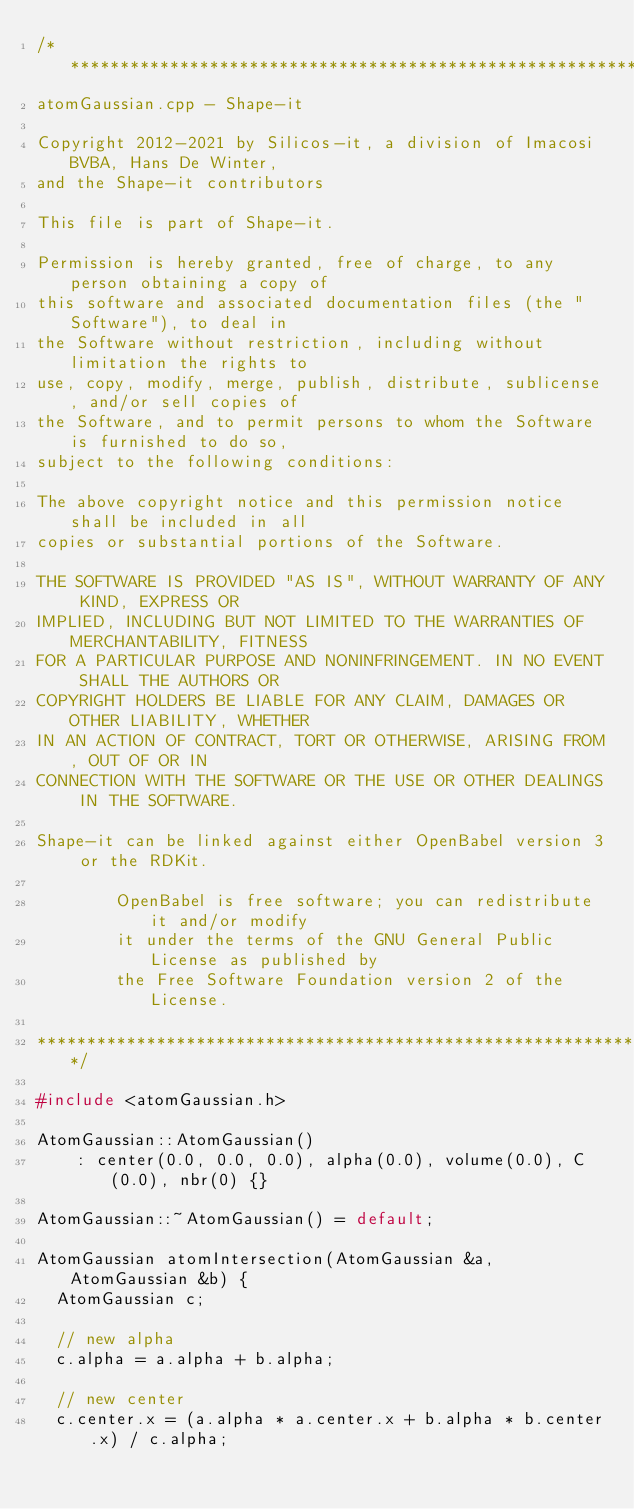<code> <loc_0><loc_0><loc_500><loc_500><_C++_>/*******************************************************************************
atomGaussian.cpp - Shape-it

Copyright 2012-2021 by Silicos-it, a division of Imacosi BVBA, Hans De Winter,
and the Shape-it contributors

This file is part of Shape-it.

Permission is hereby granted, free of charge, to any person obtaining a copy of
this software and associated documentation files (the "Software"), to deal in
the Software without restriction, including without limitation the rights to
use, copy, modify, merge, publish, distribute, sublicense, and/or sell copies of
the Software, and to permit persons to whom the Software is furnished to do so,
subject to the following conditions:

The above copyright notice and this permission notice shall be included in all
copies or substantial portions of the Software.

THE SOFTWARE IS PROVIDED "AS IS", WITHOUT WARRANTY OF ANY KIND, EXPRESS OR
IMPLIED, INCLUDING BUT NOT LIMITED TO THE WARRANTIES OF MERCHANTABILITY, FITNESS
FOR A PARTICULAR PURPOSE AND NONINFRINGEMENT. IN NO EVENT SHALL THE AUTHORS OR
COPYRIGHT HOLDERS BE LIABLE FOR ANY CLAIM, DAMAGES OR OTHER LIABILITY, WHETHER
IN AN ACTION OF CONTRACT, TORT OR OTHERWISE, ARISING FROM, OUT OF OR IN
CONNECTION WITH THE SOFTWARE OR THE USE OR OTHER DEALINGS IN THE SOFTWARE.

Shape-it can be linked against either OpenBabel version 3 or the RDKit.

        OpenBabel is free software; you can redistribute it and/or modify
        it under the terms of the GNU General Public License as published by
        the Free Software Foundation version 2 of the License.

***********************************************************************/

#include <atomGaussian.h>

AtomGaussian::AtomGaussian()
    : center(0.0, 0.0, 0.0), alpha(0.0), volume(0.0), C(0.0), nbr(0) {}

AtomGaussian::~AtomGaussian() = default;

AtomGaussian atomIntersection(AtomGaussian &a, AtomGaussian &b) {
  AtomGaussian c;

  // new alpha
  c.alpha = a.alpha + b.alpha;

  // new center
  c.center.x = (a.alpha * a.center.x + b.alpha * b.center.x) / c.alpha;</code> 